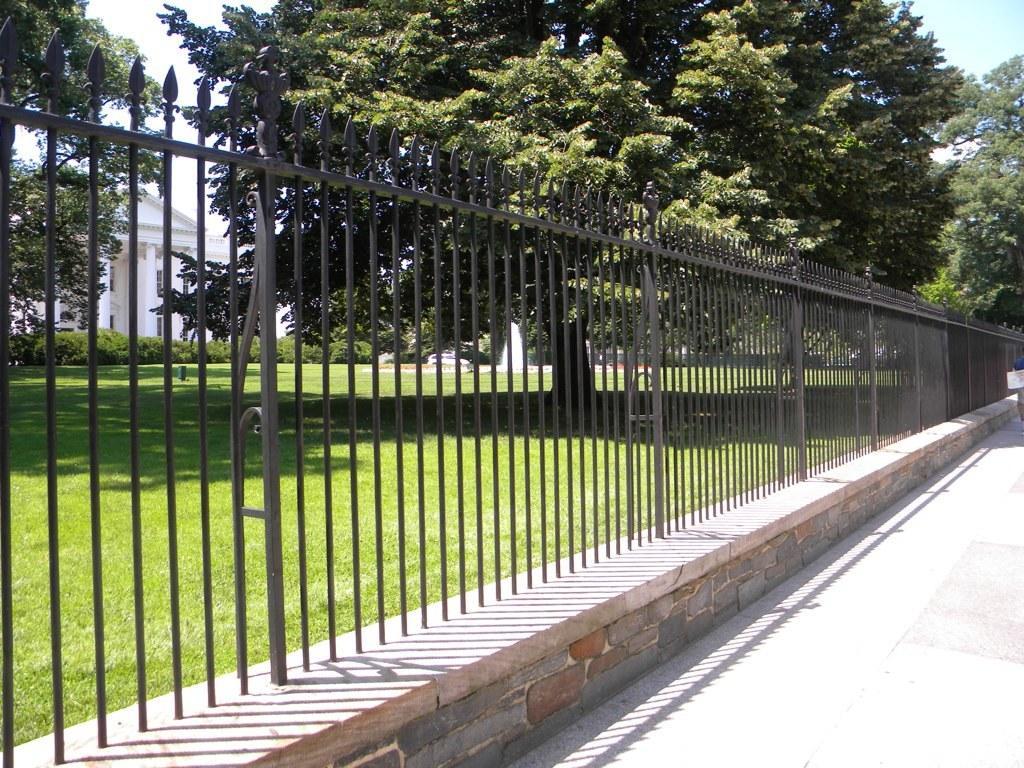Please provide a concise description of this image. In this image we can see fence on a platform and there is a footpath on the right side. In the background there are trees, plants and grass on the ground and we can also see buildings, vehicles, fountain and clouds in the sky. 